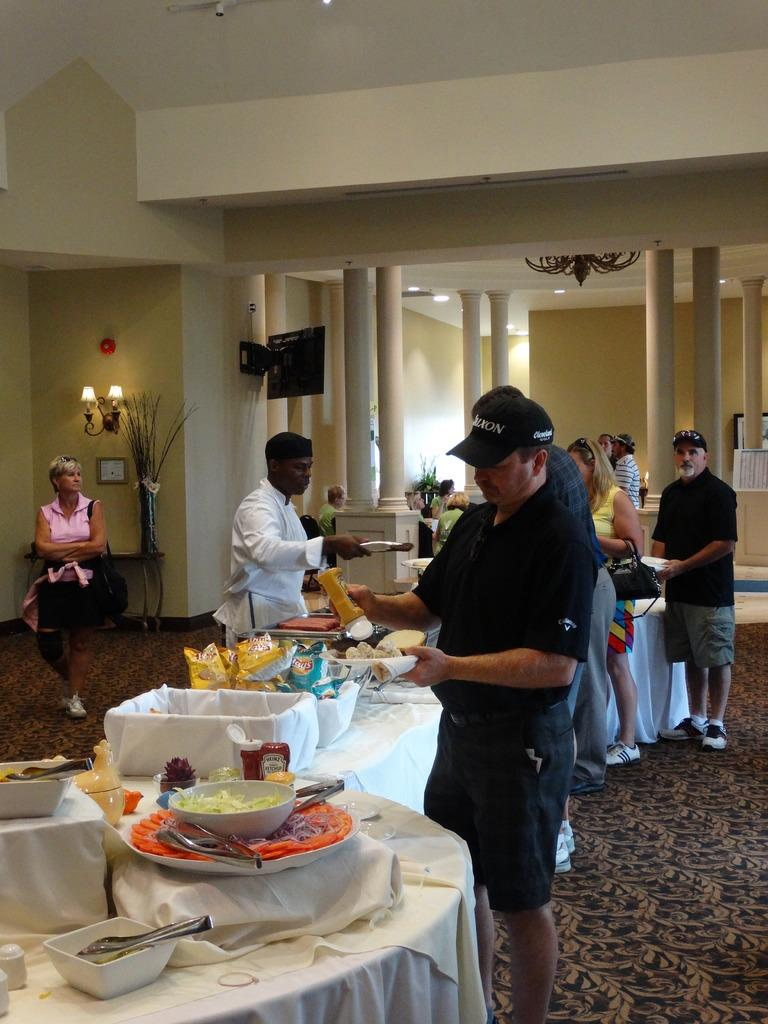What can be seen in the image involving people? There are people standing in the image. What objects are present in the image that might be used for eating or serving food? There are tables, food, and plates on the tables in the image. What can be seen in the background of the image? There is a television and lights in the background of the image. How many ladybugs are crawling on the plates in the image? There are no ladybugs present in the image; the focus is on the people, tables, food, and plates. 